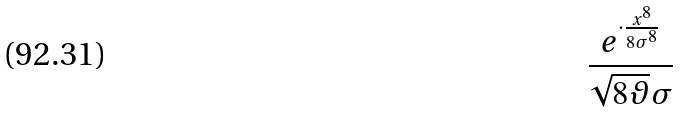<formula> <loc_0><loc_0><loc_500><loc_500>\frac { e ^ { \cdot \frac { x ^ { 8 } } { 8 \sigma ^ { 8 } } } } { \sqrt { 8 \vartheta } \sigma }</formula> 